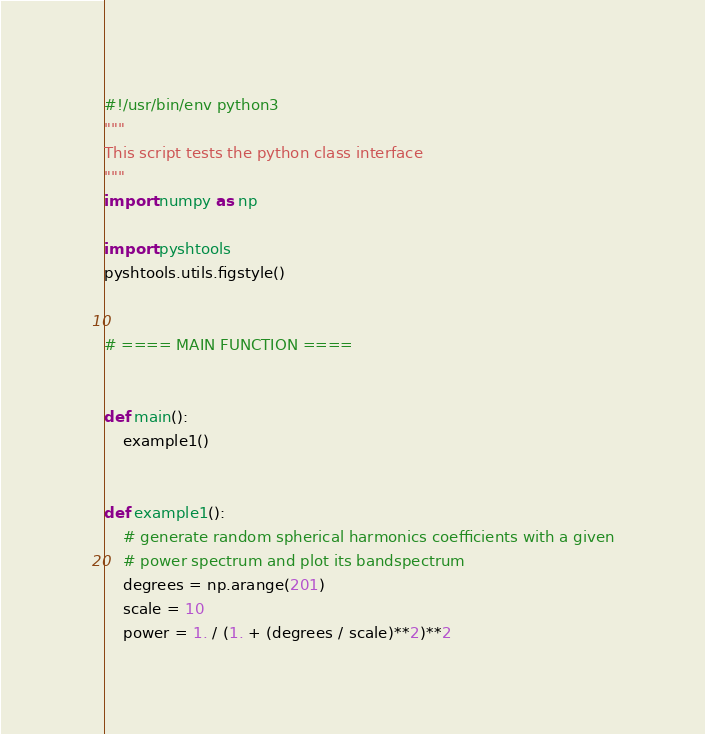Convert code to text. <code><loc_0><loc_0><loc_500><loc_500><_Python_>#!/usr/bin/env python3
"""
This script tests the python class interface
"""
import numpy as np

import pyshtools
pyshtools.utils.figstyle()


# ==== MAIN FUNCTION ====


def main():
    example1()


def example1():
    # generate random spherical harmonics coefficients with a given
    # power spectrum and plot its bandspectrum
    degrees = np.arange(201)
    scale = 10
    power = 1. / (1. + (degrees / scale)**2)**2
</code> 